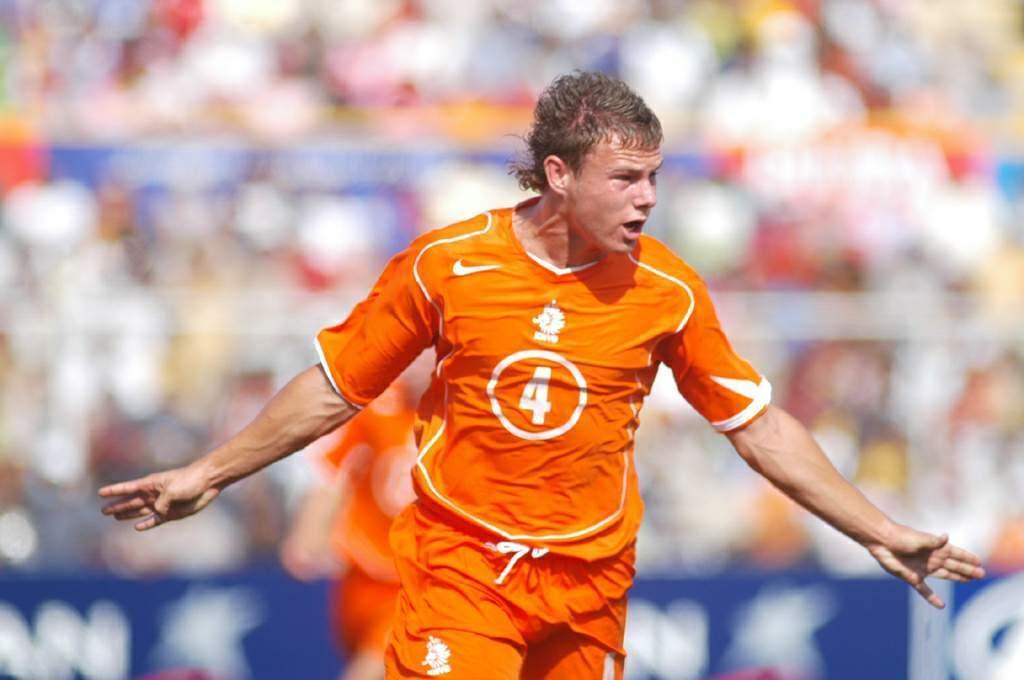Could you give a brief overview of what you see in this image? In this picture we can see a man here, he wore a t-shirt, we can see a blurry background. 